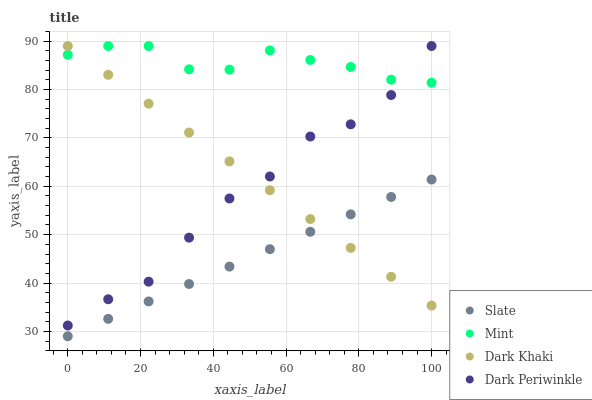Does Slate have the minimum area under the curve?
Answer yes or no. Yes. Does Mint have the maximum area under the curve?
Answer yes or no. Yes. Does Mint have the minimum area under the curve?
Answer yes or no. No. Does Slate have the maximum area under the curve?
Answer yes or no. No. Is Slate the smoothest?
Answer yes or no. Yes. Is Dark Periwinkle the roughest?
Answer yes or no. Yes. Is Mint the smoothest?
Answer yes or no. No. Is Mint the roughest?
Answer yes or no. No. Does Slate have the lowest value?
Answer yes or no. Yes. Does Mint have the lowest value?
Answer yes or no. No. Does Dark Periwinkle have the highest value?
Answer yes or no. Yes. Does Slate have the highest value?
Answer yes or no. No. Is Slate less than Mint?
Answer yes or no. Yes. Is Mint greater than Slate?
Answer yes or no. Yes. Does Mint intersect Dark Khaki?
Answer yes or no. Yes. Is Mint less than Dark Khaki?
Answer yes or no. No. Is Mint greater than Dark Khaki?
Answer yes or no. No. Does Slate intersect Mint?
Answer yes or no. No. 